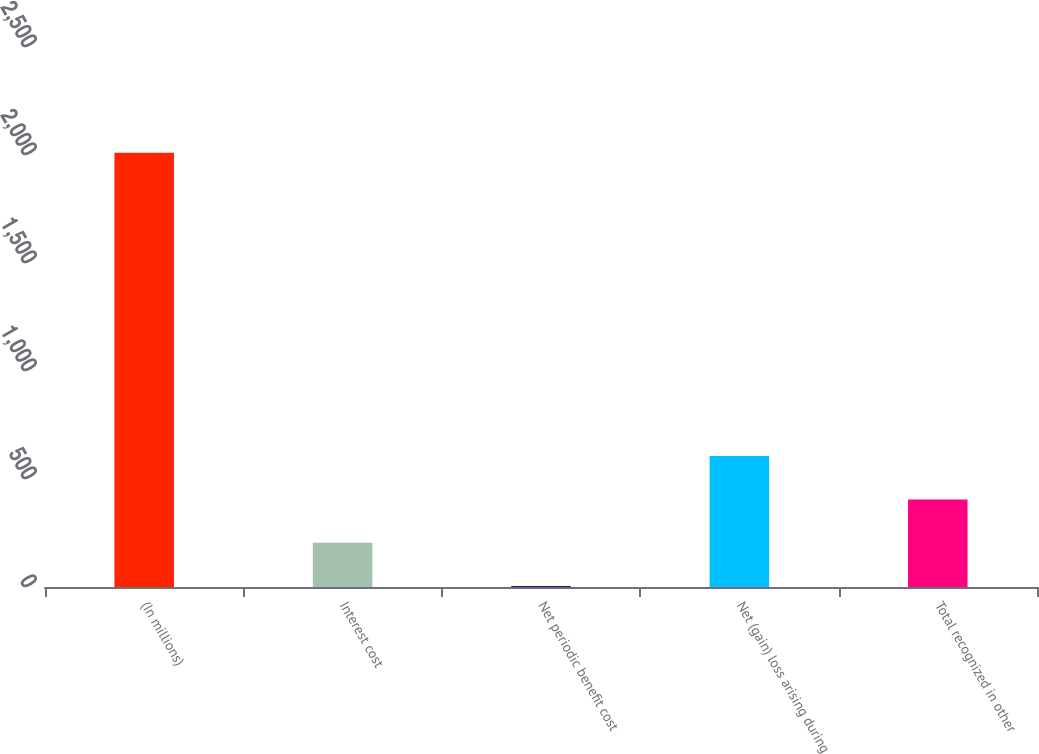Convert chart to OTSL. <chart><loc_0><loc_0><loc_500><loc_500><bar_chart><fcel>(In millions)<fcel>Interest cost<fcel>Net periodic benefit cost<fcel>Net (gain) loss arising during<fcel>Total recognized in other<nl><fcel>2010<fcel>204.87<fcel>4.3<fcel>606.01<fcel>405.44<nl></chart> 